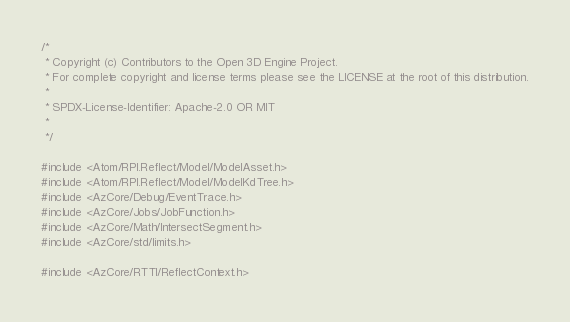Convert code to text. <code><loc_0><loc_0><loc_500><loc_500><_C++_>/*
 * Copyright (c) Contributors to the Open 3D Engine Project.
 * For complete copyright and license terms please see the LICENSE at the root of this distribution.
 *
 * SPDX-License-Identifier: Apache-2.0 OR MIT
 *
 */

#include <Atom/RPI.Reflect/Model/ModelAsset.h>
#include <Atom/RPI.Reflect/Model/ModelKdTree.h>
#include <AzCore/Debug/EventTrace.h>
#include <AzCore/Jobs/JobFunction.h>
#include <AzCore/Math/IntersectSegment.h>
#include <AzCore/std/limits.h>

#include <AzCore/RTTI/ReflectContext.h></code> 